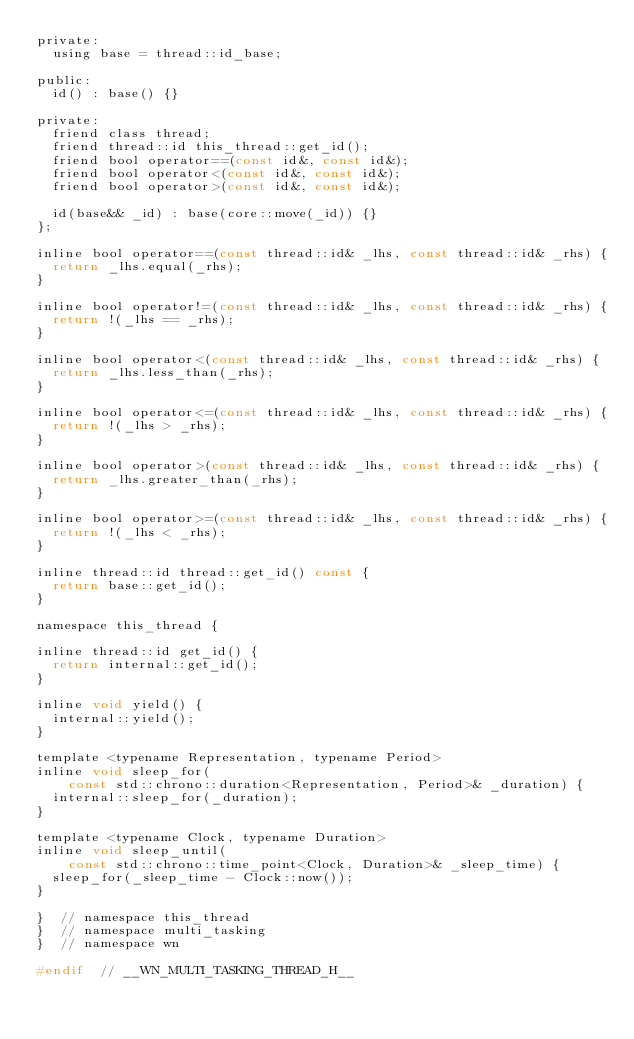Convert code to text. <code><loc_0><loc_0><loc_500><loc_500><_C_>private:
  using base = thread::id_base;

public:
  id() : base() {}

private:
  friend class thread;
  friend thread::id this_thread::get_id();
  friend bool operator==(const id&, const id&);
  friend bool operator<(const id&, const id&);
  friend bool operator>(const id&, const id&);

  id(base&& _id) : base(core::move(_id)) {}
};

inline bool operator==(const thread::id& _lhs, const thread::id& _rhs) {
  return _lhs.equal(_rhs);
}

inline bool operator!=(const thread::id& _lhs, const thread::id& _rhs) {
  return !(_lhs == _rhs);
}

inline bool operator<(const thread::id& _lhs, const thread::id& _rhs) {
  return _lhs.less_than(_rhs);
}

inline bool operator<=(const thread::id& _lhs, const thread::id& _rhs) {
  return !(_lhs > _rhs);
}

inline bool operator>(const thread::id& _lhs, const thread::id& _rhs) {
  return _lhs.greater_than(_rhs);
}

inline bool operator>=(const thread::id& _lhs, const thread::id& _rhs) {
  return !(_lhs < _rhs);
}

inline thread::id thread::get_id() const {
  return base::get_id();
}

namespace this_thread {

inline thread::id get_id() {
  return internal::get_id();
}

inline void yield() {
  internal::yield();
}

template <typename Representation, typename Period>
inline void sleep_for(
    const std::chrono::duration<Representation, Period>& _duration) {
  internal::sleep_for(_duration);
}

template <typename Clock, typename Duration>
inline void sleep_until(
    const std::chrono::time_point<Clock, Duration>& _sleep_time) {
  sleep_for(_sleep_time - Clock::now());
}

}  // namespace this_thread
}  // namespace multi_tasking
}  // namespace wn

#endif  // __WN_MULTI_TASKING_THREAD_H__
</code> 